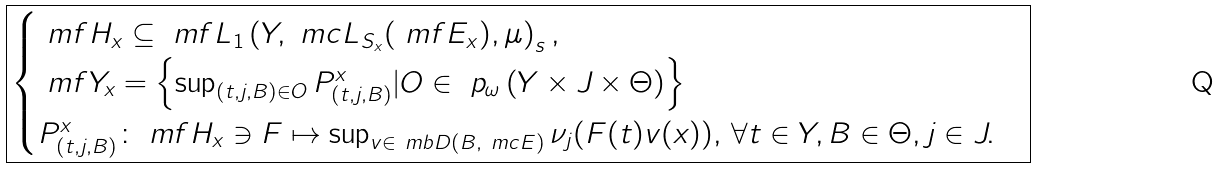Convert formula to latex. <formula><loc_0><loc_0><loc_500><loc_500>\boxed { \begin{cases} \ m f { H } _ { x } \subseteq \ m f { L } _ { 1 } \left ( Y , \ m c { L } _ { S _ { x } } ( \ m f { E } _ { x } ) , \mu \right ) _ { s } , \\ \ m f { Y } _ { x } = \left \{ \sup _ { ( t , j , B ) \in O } P _ { ( t , j , B ) } ^ { x } | O \in \ p _ { \omega } \left ( Y \times J \times \Theta \right ) \right \} \\ P _ { ( t , j , B ) } ^ { x } \colon \ m f { H } _ { x } \ni F \mapsto \sup _ { v \in \ m b { D } ( B , \ m c { E } ) } \nu _ { j } ( F ( t ) v ( x ) ) , \, \forall t \in Y , B \in \Theta , j \in J . \end{cases} }</formula> 